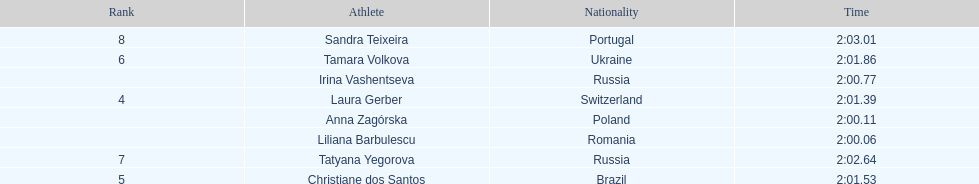The last runner crossed the finish line in 2:03.01. what was the previous time for the 7th runner? 2:02.64. 